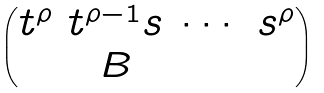Convert formula to latex. <formula><loc_0><loc_0><loc_500><loc_500>\begin{pmatrix} t ^ { \rho } & t ^ { \rho - 1 } s & \cdots & s ^ { \rho } \\ & B \end{pmatrix}</formula> 